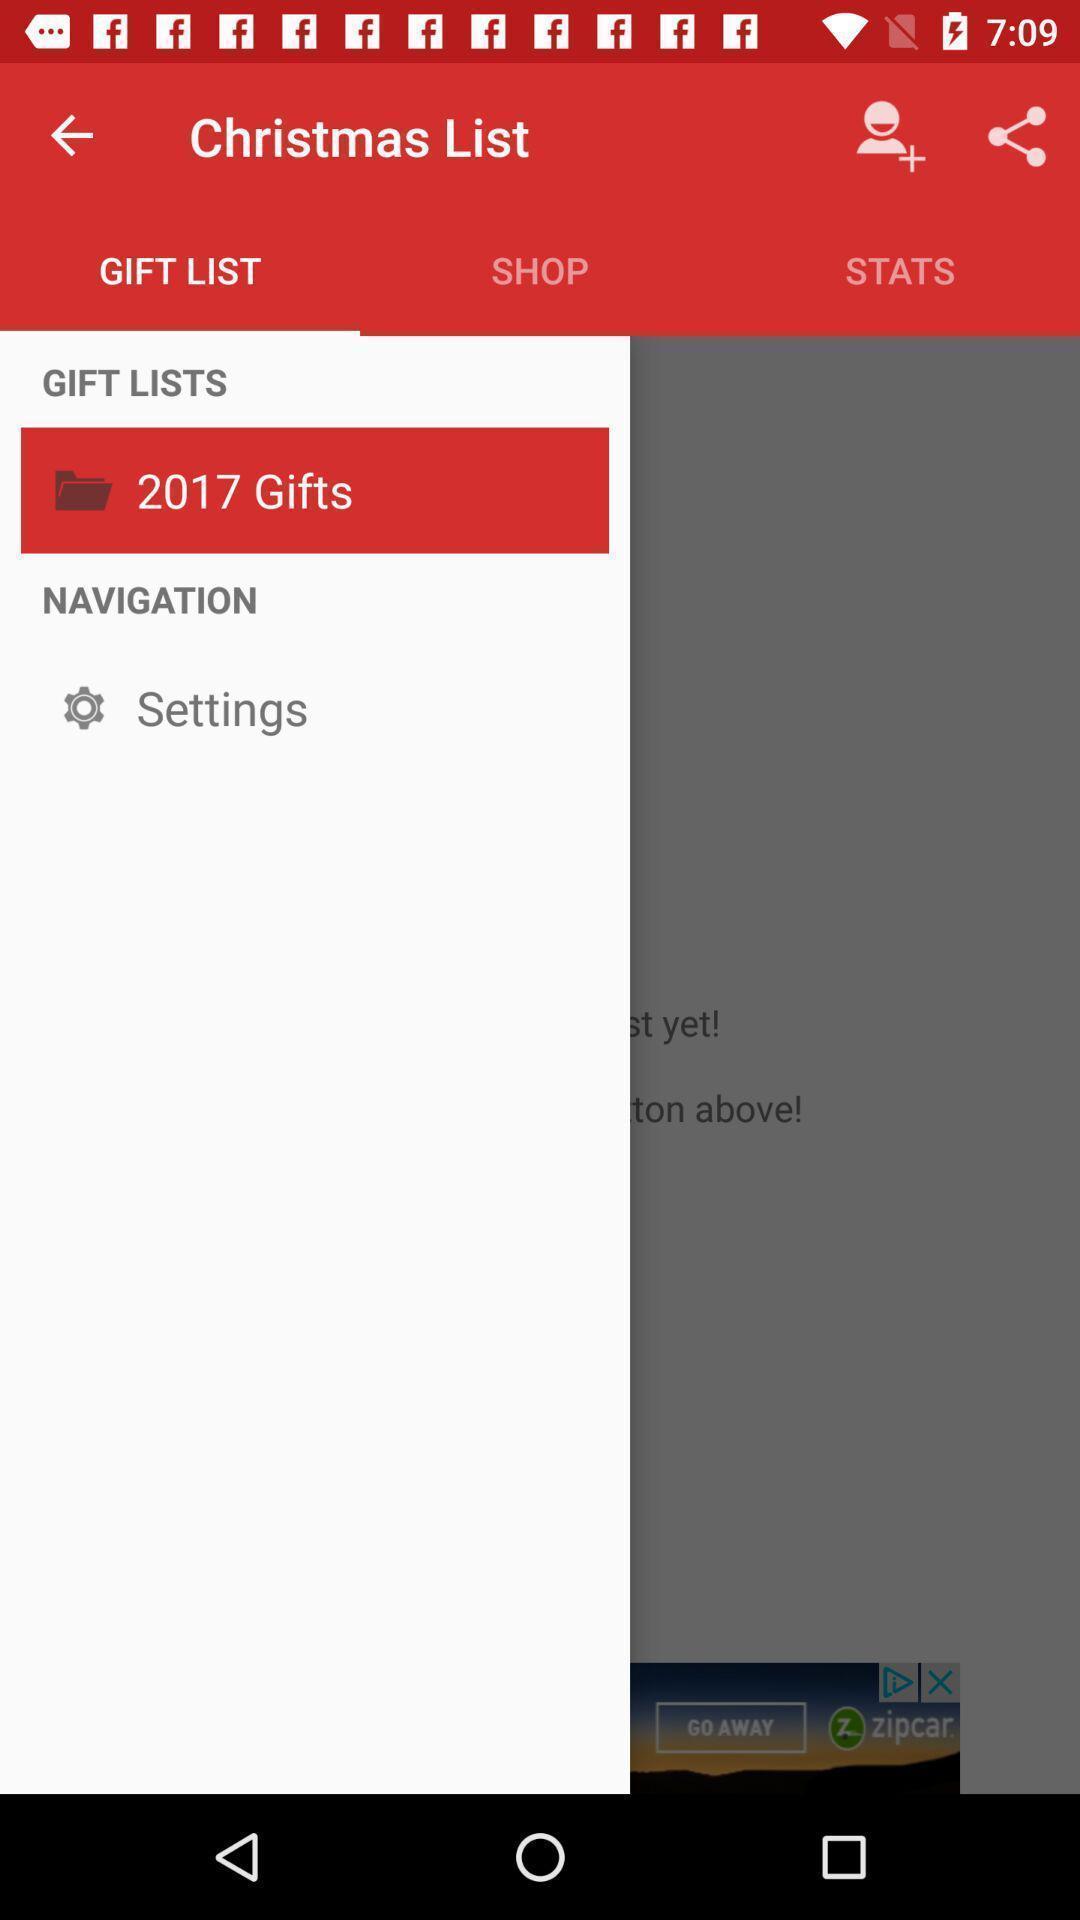Give me a narrative description of this picture. Screen shows gift list in shopping app. 